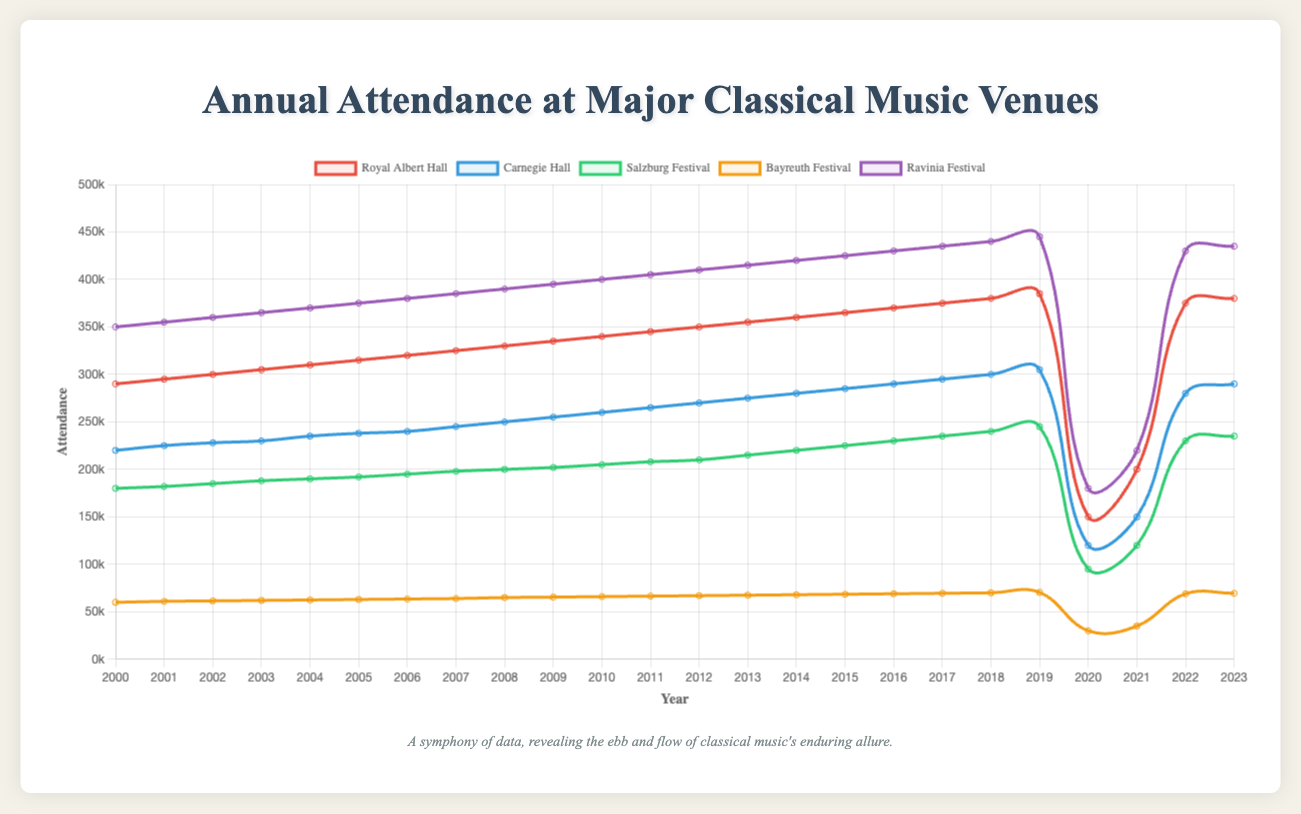What significant trend occurred in 2020 for all venues? In 2020, all venues saw a dramatic drop in attendance. This drop is significantly noticeable in the visual as all line paths sharply decrease around the 2020 mark due to the pandemic.
Answer: A sharp decline in attendance Which venue had the highest attendance in 2000 and how does it contrast with its attendance in 2023? In 2000, Ravinia Festival had the highest attendance at 350,000. By 2023, Ravinia continued to maintain high attendance, reaching 435,000, showing consistency and growth over the years.
Answer: Ravinia Festival; 350,000 in 2000 and 435,000 in 2023 Compare the attendance rates of Royal Albert Hall and Carnegie Hall in 2022. Which one had a higher attendance? In 2022, Royal Albert Hall had an attendance rate of 375,000, while Carnegie Hall had 280,000. Comparing these figures, Royal Albert Hall had a higher attendance.
Answer: Royal Albert Hall Calculate the average attendance at the Salzburg Festival from 2010 to 2019. The attendance values from 2010 to 2019 for the Salzburg Festival are: 205,000, 208,000, 210,000, 215,000, 220,000, 225,000, 230,000, 235,000, 240,000, 245,000. Summing these gives 2,233,000 and dividing by 10 gives 223,300.
Answer: 223,300 Evaluate the variation in Bayreuth Festival’s attendance from 2000 to 2023. In 2000, the Bayreuth Festival had an attendance rate of 60,000, and in 2023, the attendance was 69,500. The overall increase is 9,500 over these years, showing a slight growth in attendance.
Answer: Increased by 9,500 How did the attendance rates at Royal Albert Hall evolve from 2000 to 2019? From 2000 to 2019, the attendance at the Royal Albert Hall increased consistently each year, starting at 290,000 in 2000 and rising to 385,000 by 2019. The growth was steady without any significant drops until 2020.
Answer: Consistent increase from 290,000 to 385,000 Among the venues, which one rebounded the most in attendance from 2021 to 2022? The Royal Albert Hall showed the most significant rebound, with attendance increasing from 200,000 in 2021 to 375,000 in 2022, indicating a difference of 175,000.
Answer: Royal Albert Hall What is the total attendance of all venues in 2010? In 2010, the attendance figures were: Royal Albert Hall 340,000, Carnegie Hall 260,000, Salzburg Festival 205,000, Bayreuth Festival 66,000, and Ravinia Festival 400,000. Summing these gives 1,271,000.
Answer: 1,271,000 Identify the year with the lowest overall attendance across all venues. The year 2020 saw the lowest overall attendance, with figures significantly reduced for all venues (Royal Albert Hall, Carnegie Hall, Salzburg Festival, Bayreuth Festival, and Ravinia Festival) due to the pandemic. This pattern is visually clear with a major dip in all the lines representing each venue.
Answer: 2020 